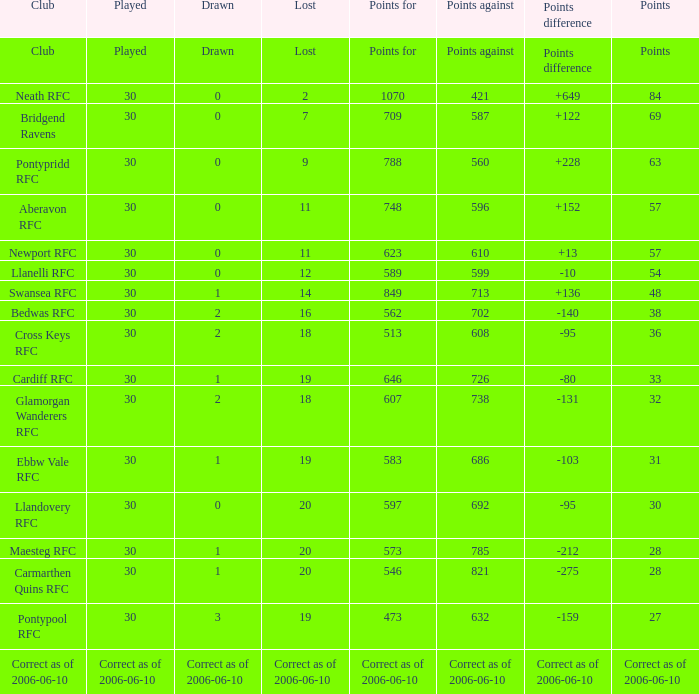Parse the full table. {'header': ['Club', 'Played', 'Drawn', 'Lost', 'Points for', 'Points against', 'Points difference', 'Points'], 'rows': [['Club', 'Played', 'Drawn', 'Lost', 'Points for', 'Points against', 'Points difference', 'Points'], ['Neath RFC', '30', '0', '2', '1070', '421', '+649', '84'], ['Bridgend Ravens', '30', '0', '7', '709', '587', '+122', '69'], ['Pontypridd RFC', '30', '0', '9', '788', '560', '+228', '63'], ['Aberavon RFC', '30', '0', '11', '748', '596', '+152', '57'], ['Newport RFC', '30', '0', '11', '623', '610', '+13', '57'], ['Llanelli RFC', '30', '0', '12', '589', '599', '-10', '54'], ['Swansea RFC', '30', '1', '14', '849', '713', '+136', '48'], ['Bedwas RFC', '30', '2', '16', '562', '702', '-140', '38'], ['Cross Keys RFC', '30', '2', '18', '513', '608', '-95', '36'], ['Cardiff RFC', '30', '1', '19', '646', '726', '-80', '33'], ['Glamorgan Wanderers RFC', '30', '2', '18', '607', '738', '-131', '32'], ['Ebbw Vale RFC', '30', '1', '19', '583', '686', '-103', '31'], ['Llandovery RFC', '30', '0', '20', '597', '692', '-95', '30'], ['Maesteg RFC', '30', '1', '20', '573', '785', '-212', '28'], ['Carmarthen Quins RFC', '30', '1', '20', '546', '821', '-275', '28'], ['Pontypool RFC', '30', '3', '19', '473', '632', '-159', '27'], ['Correct as of 2006-06-10', 'Correct as of 2006-06-10', 'Correct as of 2006-06-10', 'Correct as of 2006-06-10', 'Correct as of 2006-06-10', 'Correct as of 2006-06-10', 'Correct as of 2006-06-10', 'Correct as of 2006-06-10']]} What is absent, when sketched is "2", and when positions is "36"? 18.0. 